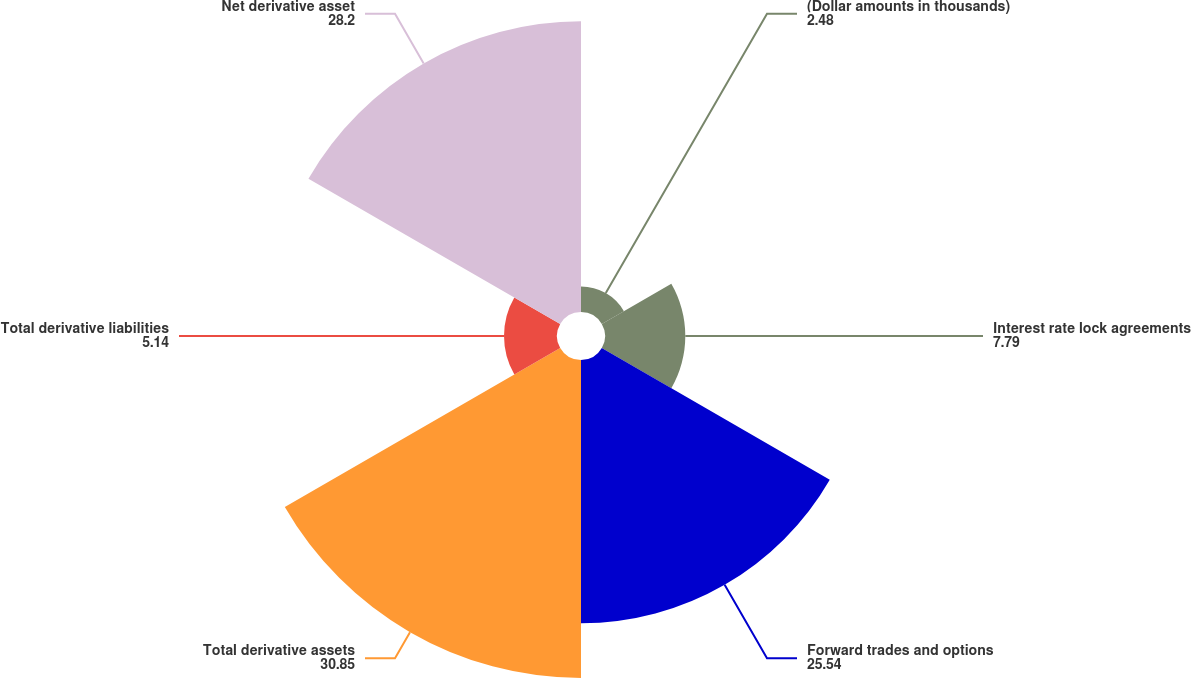Convert chart to OTSL. <chart><loc_0><loc_0><loc_500><loc_500><pie_chart><fcel>(Dollar amounts in thousands)<fcel>Interest rate lock agreements<fcel>Forward trades and options<fcel>Total derivative assets<fcel>Total derivative liabilities<fcel>Net derivative asset<nl><fcel>2.48%<fcel>7.79%<fcel>25.54%<fcel>30.85%<fcel>5.14%<fcel>28.2%<nl></chart> 